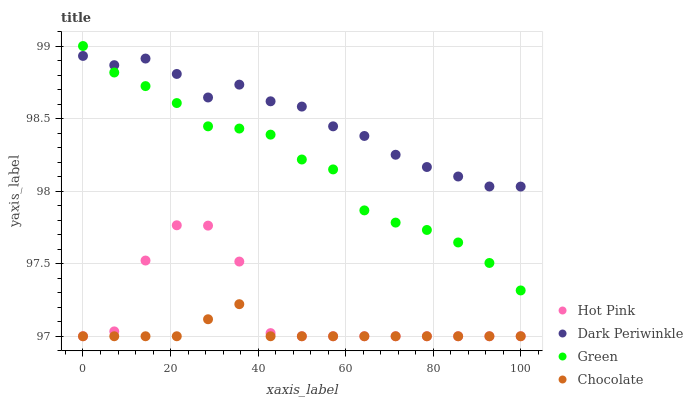Does Chocolate have the minimum area under the curve?
Answer yes or no. Yes. Does Dark Periwinkle have the maximum area under the curve?
Answer yes or no. Yes. Does Green have the minimum area under the curve?
Answer yes or no. No. Does Green have the maximum area under the curve?
Answer yes or no. No. Is Chocolate the smoothest?
Answer yes or no. Yes. Is Hot Pink the roughest?
Answer yes or no. Yes. Is Green the smoothest?
Answer yes or no. No. Is Green the roughest?
Answer yes or no. No. Does Hot Pink have the lowest value?
Answer yes or no. Yes. Does Green have the lowest value?
Answer yes or no. No. Does Green have the highest value?
Answer yes or no. Yes. Does Dark Periwinkle have the highest value?
Answer yes or no. No. Is Chocolate less than Dark Periwinkle?
Answer yes or no. Yes. Is Dark Periwinkle greater than Chocolate?
Answer yes or no. Yes. Does Dark Periwinkle intersect Green?
Answer yes or no. Yes. Is Dark Periwinkle less than Green?
Answer yes or no. No. Is Dark Periwinkle greater than Green?
Answer yes or no. No. Does Chocolate intersect Dark Periwinkle?
Answer yes or no. No. 